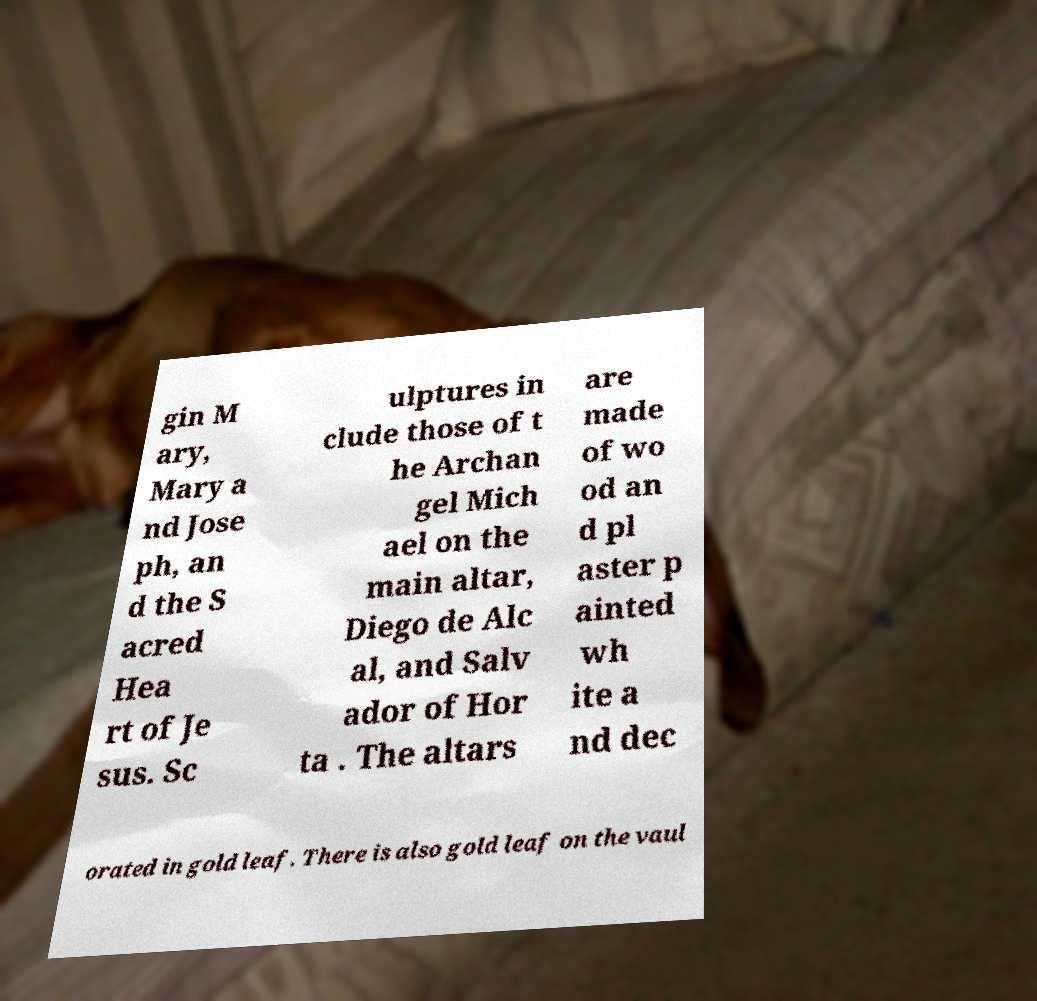Can you accurately transcribe the text from the provided image for me? gin M ary, Mary a nd Jose ph, an d the S acred Hea rt of Je sus. Sc ulptures in clude those of t he Archan gel Mich ael on the main altar, Diego de Alc al, and Salv ador of Hor ta . The altars are made of wo od an d pl aster p ainted wh ite a nd dec orated in gold leaf. There is also gold leaf on the vaul 